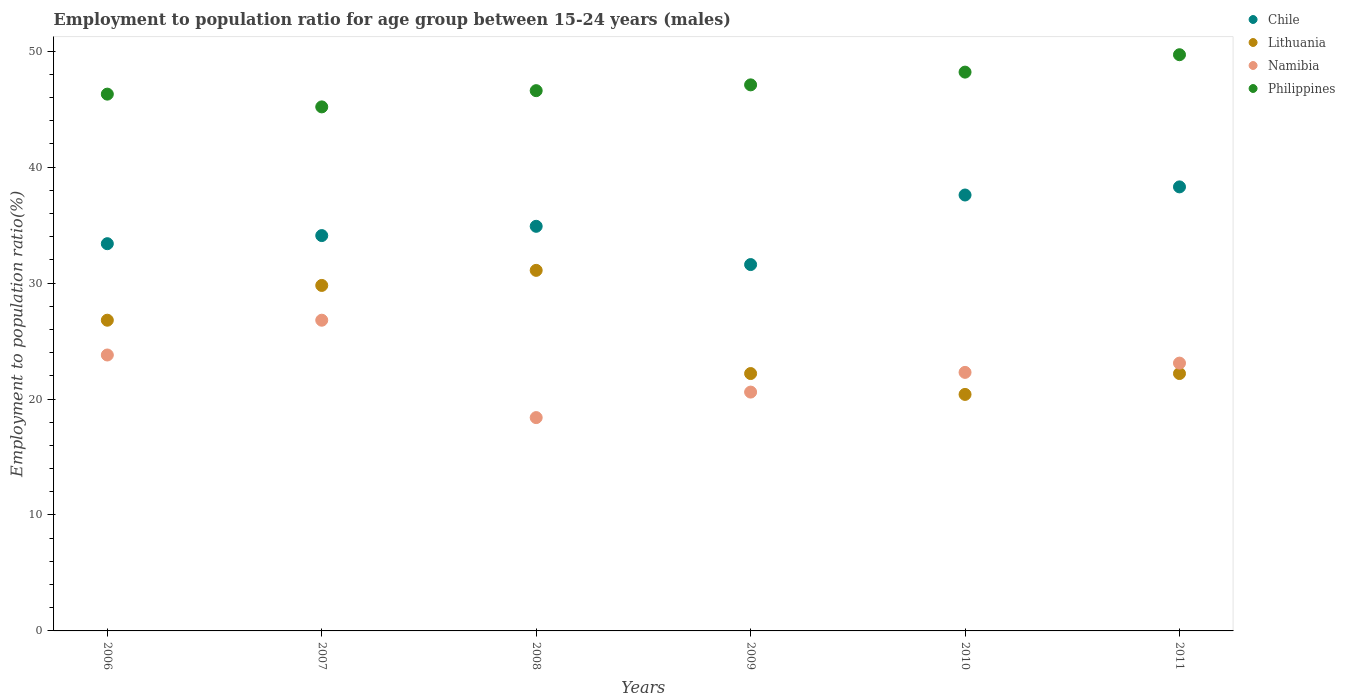What is the employment to population ratio in Namibia in 2009?
Provide a short and direct response. 20.6. Across all years, what is the maximum employment to population ratio in Philippines?
Your answer should be compact. 49.7. Across all years, what is the minimum employment to population ratio in Lithuania?
Your response must be concise. 20.4. In which year was the employment to population ratio in Philippines maximum?
Make the answer very short. 2011. In which year was the employment to population ratio in Philippines minimum?
Make the answer very short. 2007. What is the total employment to population ratio in Namibia in the graph?
Your answer should be very brief. 135. What is the difference between the employment to population ratio in Namibia in 2009 and that in 2010?
Your answer should be compact. -1.7. What is the difference between the employment to population ratio in Lithuania in 2007 and the employment to population ratio in Philippines in 2010?
Give a very brief answer. -18.4. What is the average employment to population ratio in Lithuania per year?
Make the answer very short. 25.42. In the year 2007, what is the difference between the employment to population ratio in Chile and employment to population ratio in Namibia?
Offer a very short reply. 7.3. What is the ratio of the employment to population ratio in Namibia in 2009 to that in 2010?
Give a very brief answer. 0.92. Is the difference between the employment to population ratio in Chile in 2006 and 2007 greater than the difference between the employment to population ratio in Namibia in 2006 and 2007?
Provide a short and direct response. Yes. What is the difference between the highest and the second highest employment to population ratio in Lithuania?
Keep it short and to the point. 1.3. What is the difference between the highest and the lowest employment to population ratio in Lithuania?
Offer a terse response. 10.7. In how many years, is the employment to population ratio in Philippines greater than the average employment to population ratio in Philippines taken over all years?
Give a very brief answer. 2. Does the employment to population ratio in Philippines monotonically increase over the years?
Your answer should be compact. No. How many dotlines are there?
Offer a terse response. 4. Are the values on the major ticks of Y-axis written in scientific E-notation?
Ensure brevity in your answer.  No. Does the graph contain grids?
Your answer should be compact. No. Where does the legend appear in the graph?
Give a very brief answer. Top right. How are the legend labels stacked?
Give a very brief answer. Vertical. What is the title of the graph?
Make the answer very short. Employment to population ratio for age group between 15-24 years (males). What is the label or title of the Y-axis?
Offer a terse response. Employment to population ratio(%). What is the Employment to population ratio(%) of Chile in 2006?
Offer a very short reply. 33.4. What is the Employment to population ratio(%) in Lithuania in 2006?
Offer a very short reply. 26.8. What is the Employment to population ratio(%) in Namibia in 2006?
Provide a short and direct response. 23.8. What is the Employment to population ratio(%) in Philippines in 2006?
Make the answer very short. 46.3. What is the Employment to population ratio(%) of Chile in 2007?
Your answer should be very brief. 34.1. What is the Employment to population ratio(%) in Lithuania in 2007?
Make the answer very short. 29.8. What is the Employment to population ratio(%) of Namibia in 2007?
Your response must be concise. 26.8. What is the Employment to population ratio(%) of Philippines in 2007?
Your answer should be very brief. 45.2. What is the Employment to population ratio(%) of Chile in 2008?
Keep it short and to the point. 34.9. What is the Employment to population ratio(%) in Lithuania in 2008?
Your answer should be compact. 31.1. What is the Employment to population ratio(%) of Namibia in 2008?
Your response must be concise. 18.4. What is the Employment to population ratio(%) in Philippines in 2008?
Your answer should be very brief. 46.6. What is the Employment to population ratio(%) in Chile in 2009?
Keep it short and to the point. 31.6. What is the Employment to population ratio(%) in Lithuania in 2009?
Provide a succinct answer. 22.2. What is the Employment to population ratio(%) in Namibia in 2009?
Provide a short and direct response. 20.6. What is the Employment to population ratio(%) of Philippines in 2009?
Your answer should be compact. 47.1. What is the Employment to population ratio(%) in Chile in 2010?
Provide a short and direct response. 37.6. What is the Employment to population ratio(%) in Lithuania in 2010?
Offer a terse response. 20.4. What is the Employment to population ratio(%) in Namibia in 2010?
Give a very brief answer. 22.3. What is the Employment to population ratio(%) of Philippines in 2010?
Provide a succinct answer. 48.2. What is the Employment to population ratio(%) of Chile in 2011?
Provide a succinct answer. 38.3. What is the Employment to population ratio(%) in Lithuania in 2011?
Keep it short and to the point. 22.2. What is the Employment to population ratio(%) in Namibia in 2011?
Offer a very short reply. 23.1. What is the Employment to population ratio(%) of Philippines in 2011?
Make the answer very short. 49.7. Across all years, what is the maximum Employment to population ratio(%) in Chile?
Ensure brevity in your answer.  38.3. Across all years, what is the maximum Employment to population ratio(%) in Lithuania?
Provide a short and direct response. 31.1. Across all years, what is the maximum Employment to population ratio(%) in Namibia?
Make the answer very short. 26.8. Across all years, what is the maximum Employment to population ratio(%) in Philippines?
Your answer should be compact. 49.7. Across all years, what is the minimum Employment to population ratio(%) in Chile?
Keep it short and to the point. 31.6. Across all years, what is the minimum Employment to population ratio(%) in Lithuania?
Your answer should be compact. 20.4. Across all years, what is the minimum Employment to population ratio(%) of Namibia?
Provide a short and direct response. 18.4. Across all years, what is the minimum Employment to population ratio(%) of Philippines?
Provide a succinct answer. 45.2. What is the total Employment to population ratio(%) in Chile in the graph?
Offer a terse response. 209.9. What is the total Employment to population ratio(%) in Lithuania in the graph?
Ensure brevity in your answer.  152.5. What is the total Employment to population ratio(%) in Namibia in the graph?
Make the answer very short. 135. What is the total Employment to population ratio(%) in Philippines in the graph?
Your answer should be very brief. 283.1. What is the difference between the Employment to population ratio(%) in Chile in 2006 and that in 2007?
Make the answer very short. -0.7. What is the difference between the Employment to population ratio(%) of Lithuania in 2006 and that in 2007?
Make the answer very short. -3. What is the difference between the Employment to population ratio(%) of Namibia in 2006 and that in 2007?
Offer a very short reply. -3. What is the difference between the Employment to population ratio(%) in Lithuania in 2006 and that in 2008?
Your response must be concise. -4.3. What is the difference between the Employment to population ratio(%) in Lithuania in 2006 and that in 2009?
Keep it short and to the point. 4.6. What is the difference between the Employment to population ratio(%) of Namibia in 2006 and that in 2010?
Ensure brevity in your answer.  1.5. What is the difference between the Employment to population ratio(%) of Chile in 2006 and that in 2011?
Provide a succinct answer. -4.9. What is the difference between the Employment to population ratio(%) of Lithuania in 2006 and that in 2011?
Provide a succinct answer. 4.6. What is the difference between the Employment to population ratio(%) in Philippines in 2006 and that in 2011?
Your answer should be very brief. -3.4. What is the difference between the Employment to population ratio(%) of Lithuania in 2007 and that in 2008?
Provide a short and direct response. -1.3. What is the difference between the Employment to population ratio(%) of Philippines in 2007 and that in 2008?
Make the answer very short. -1.4. What is the difference between the Employment to population ratio(%) in Chile in 2007 and that in 2009?
Your response must be concise. 2.5. What is the difference between the Employment to population ratio(%) in Lithuania in 2007 and that in 2009?
Ensure brevity in your answer.  7.6. What is the difference between the Employment to population ratio(%) in Philippines in 2007 and that in 2009?
Offer a terse response. -1.9. What is the difference between the Employment to population ratio(%) of Chile in 2007 and that in 2010?
Give a very brief answer. -3.5. What is the difference between the Employment to population ratio(%) in Namibia in 2007 and that in 2010?
Your answer should be very brief. 4.5. What is the difference between the Employment to population ratio(%) of Chile in 2007 and that in 2011?
Keep it short and to the point. -4.2. What is the difference between the Employment to population ratio(%) of Namibia in 2007 and that in 2011?
Provide a short and direct response. 3.7. What is the difference between the Employment to population ratio(%) of Philippines in 2007 and that in 2011?
Offer a very short reply. -4.5. What is the difference between the Employment to population ratio(%) in Chile in 2008 and that in 2009?
Your answer should be compact. 3.3. What is the difference between the Employment to population ratio(%) of Philippines in 2008 and that in 2009?
Give a very brief answer. -0.5. What is the difference between the Employment to population ratio(%) in Lithuania in 2008 and that in 2010?
Your response must be concise. 10.7. What is the difference between the Employment to population ratio(%) in Philippines in 2008 and that in 2010?
Give a very brief answer. -1.6. What is the difference between the Employment to population ratio(%) of Lithuania in 2008 and that in 2011?
Offer a very short reply. 8.9. What is the difference between the Employment to population ratio(%) of Namibia in 2009 and that in 2010?
Keep it short and to the point. -1.7. What is the difference between the Employment to population ratio(%) of Philippines in 2009 and that in 2010?
Ensure brevity in your answer.  -1.1. What is the difference between the Employment to population ratio(%) of Namibia in 2009 and that in 2011?
Offer a terse response. -2.5. What is the difference between the Employment to population ratio(%) of Philippines in 2009 and that in 2011?
Offer a very short reply. -2.6. What is the difference between the Employment to population ratio(%) of Lithuania in 2010 and that in 2011?
Keep it short and to the point. -1.8. What is the difference between the Employment to population ratio(%) of Namibia in 2010 and that in 2011?
Ensure brevity in your answer.  -0.8. What is the difference between the Employment to population ratio(%) of Chile in 2006 and the Employment to population ratio(%) of Philippines in 2007?
Your response must be concise. -11.8. What is the difference between the Employment to population ratio(%) in Lithuania in 2006 and the Employment to population ratio(%) in Philippines in 2007?
Keep it short and to the point. -18.4. What is the difference between the Employment to population ratio(%) in Namibia in 2006 and the Employment to population ratio(%) in Philippines in 2007?
Your response must be concise. -21.4. What is the difference between the Employment to population ratio(%) in Chile in 2006 and the Employment to population ratio(%) in Lithuania in 2008?
Provide a succinct answer. 2.3. What is the difference between the Employment to population ratio(%) of Chile in 2006 and the Employment to population ratio(%) of Namibia in 2008?
Make the answer very short. 15. What is the difference between the Employment to population ratio(%) in Chile in 2006 and the Employment to population ratio(%) in Philippines in 2008?
Your answer should be very brief. -13.2. What is the difference between the Employment to population ratio(%) in Lithuania in 2006 and the Employment to population ratio(%) in Namibia in 2008?
Offer a terse response. 8.4. What is the difference between the Employment to population ratio(%) in Lithuania in 2006 and the Employment to population ratio(%) in Philippines in 2008?
Give a very brief answer. -19.8. What is the difference between the Employment to population ratio(%) of Namibia in 2006 and the Employment to population ratio(%) of Philippines in 2008?
Ensure brevity in your answer.  -22.8. What is the difference between the Employment to population ratio(%) in Chile in 2006 and the Employment to population ratio(%) in Lithuania in 2009?
Make the answer very short. 11.2. What is the difference between the Employment to population ratio(%) of Chile in 2006 and the Employment to population ratio(%) of Namibia in 2009?
Your response must be concise. 12.8. What is the difference between the Employment to population ratio(%) of Chile in 2006 and the Employment to population ratio(%) of Philippines in 2009?
Keep it short and to the point. -13.7. What is the difference between the Employment to population ratio(%) in Lithuania in 2006 and the Employment to population ratio(%) in Philippines in 2009?
Ensure brevity in your answer.  -20.3. What is the difference between the Employment to population ratio(%) of Namibia in 2006 and the Employment to population ratio(%) of Philippines in 2009?
Provide a succinct answer. -23.3. What is the difference between the Employment to population ratio(%) of Chile in 2006 and the Employment to population ratio(%) of Namibia in 2010?
Keep it short and to the point. 11.1. What is the difference between the Employment to population ratio(%) of Chile in 2006 and the Employment to population ratio(%) of Philippines in 2010?
Give a very brief answer. -14.8. What is the difference between the Employment to population ratio(%) of Lithuania in 2006 and the Employment to population ratio(%) of Namibia in 2010?
Keep it short and to the point. 4.5. What is the difference between the Employment to population ratio(%) in Lithuania in 2006 and the Employment to population ratio(%) in Philippines in 2010?
Your response must be concise. -21.4. What is the difference between the Employment to population ratio(%) in Namibia in 2006 and the Employment to population ratio(%) in Philippines in 2010?
Keep it short and to the point. -24.4. What is the difference between the Employment to population ratio(%) in Chile in 2006 and the Employment to population ratio(%) in Lithuania in 2011?
Give a very brief answer. 11.2. What is the difference between the Employment to population ratio(%) of Chile in 2006 and the Employment to population ratio(%) of Namibia in 2011?
Your answer should be very brief. 10.3. What is the difference between the Employment to population ratio(%) of Chile in 2006 and the Employment to population ratio(%) of Philippines in 2011?
Make the answer very short. -16.3. What is the difference between the Employment to population ratio(%) of Lithuania in 2006 and the Employment to population ratio(%) of Namibia in 2011?
Offer a terse response. 3.7. What is the difference between the Employment to population ratio(%) of Lithuania in 2006 and the Employment to population ratio(%) of Philippines in 2011?
Keep it short and to the point. -22.9. What is the difference between the Employment to population ratio(%) of Namibia in 2006 and the Employment to population ratio(%) of Philippines in 2011?
Offer a terse response. -25.9. What is the difference between the Employment to population ratio(%) of Chile in 2007 and the Employment to population ratio(%) of Namibia in 2008?
Provide a succinct answer. 15.7. What is the difference between the Employment to population ratio(%) in Lithuania in 2007 and the Employment to population ratio(%) in Philippines in 2008?
Offer a very short reply. -16.8. What is the difference between the Employment to population ratio(%) of Namibia in 2007 and the Employment to population ratio(%) of Philippines in 2008?
Make the answer very short. -19.8. What is the difference between the Employment to population ratio(%) in Chile in 2007 and the Employment to population ratio(%) in Lithuania in 2009?
Make the answer very short. 11.9. What is the difference between the Employment to population ratio(%) in Chile in 2007 and the Employment to population ratio(%) in Namibia in 2009?
Your answer should be compact. 13.5. What is the difference between the Employment to population ratio(%) of Lithuania in 2007 and the Employment to population ratio(%) of Namibia in 2009?
Your response must be concise. 9.2. What is the difference between the Employment to population ratio(%) in Lithuania in 2007 and the Employment to population ratio(%) in Philippines in 2009?
Keep it short and to the point. -17.3. What is the difference between the Employment to population ratio(%) in Namibia in 2007 and the Employment to population ratio(%) in Philippines in 2009?
Give a very brief answer. -20.3. What is the difference between the Employment to population ratio(%) of Chile in 2007 and the Employment to population ratio(%) of Namibia in 2010?
Ensure brevity in your answer.  11.8. What is the difference between the Employment to population ratio(%) of Chile in 2007 and the Employment to population ratio(%) of Philippines in 2010?
Your response must be concise. -14.1. What is the difference between the Employment to population ratio(%) of Lithuania in 2007 and the Employment to population ratio(%) of Namibia in 2010?
Ensure brevity in your answer.  7.5. What is the difference between the Employment to population ratio(%) in Lithuania in 2007 and the Employment to population ratio(%) in Philippines in 2010?
Your answer should be compact. -18.4. What is the difference between the Employment to population ratio(%) in Namibia in 2007 and the Employment to population ratio(%) in Philippines in 2010?
Keep it short and to the point. -21.4. What is the difference between the Employment to population ratio(%) of Chile in 2007 and the Employment to population ratio(%) of Lithuania in 2011?
Provide a succinct answer. 11.9. What is the difference between the Employment to population ratio(%) in Chile in 2007 and the Employment to population ratio(%) in Philippines in 2011?
Your response must be concise. -15.6. What is the difference between the Employment to population ratio(%) in Lithuania in 2007 and the Employment to population ratio(%) in Philippines in 2011?
Your response must be concise. -19.9. What is the difference between the Employment to population ratio(%) of Namibia in 2007 and the Employment to population ratio(%) of Philippines in 2011?
Ensure brevity in your answer.  -22.9. What is the difference between the Employment to population ratio(%) of Chile in 2008 and the Employment to population ratio(%) of Lithuania in 2009?
Give a very brief answer. 12.7. What is the difference between the Employment to population ratio(%) in Chile in 2008 and the Employment to population ratio(%) in Namibia in 2009?
Provide a succinct answer. 14.3. What is the difference between the Employment to population ratio(%) of Lithuania in 2008 and the Employment to population ratio(%) of Namibia in 2009?
Your response must be concise. 10.5. What is the difference between the Employment to population ratio(%) in Lithuania in 2008 and the Employment to population ratio(%) in Philippines in 2009?
Provide a succinct answer. -16. What is the difference between the Employment to population ratio(%) of Namibia in 2008 and the Employment to population ratio(%) of Philippines in 2009?
Ensure brevity in your answer.  -28.7. What is the difference between the Employment to population ratio(%) in Chile in 2008 and the Employment to population ratio(%) in Philippines in 2010?
Give a very brief answer. -13.3. What is the difference between the Employment to population ratio(%) in Lithuania in 2008 and the Employment to population ratio(%) in Philippines in 2010?
Provide a succinct answer. -17.1. What is the difference between the Employment to population ratio(%) in Namibia in 2008 and the Employment to population ratio(%) in Philippines in 2010?
Ensure brevity in your answer.  -29.8. What is the difference between the Employment to population ratio(%) of Chile in 2008 and the Employment to population ratio(%) of Lithuania in 2011?
Keep it short and to the point. 12.7. What is the difference between the Employment to population ratio(%) of Chile in 2008 and the Employment to population ratio(%) of Philippines in 2011?
Your response must be concise. -14.8. What is the difference between the Employment to population ratio(%) of Lithuania in 2008 and the Employment to population ratio(%) of Philippines in 2011?
Your answer should be compact. -18.6. What is the difference between the Employment to population ratio(%) in Namibia in 2008 and the Employment to population ratio(%) in Philippines in 2011?
Provide a short and direct response. -31.3. What is the difference between the Employment to population ratio(%) of Chile in 2009 and the Employment to population ratio(%) of Namibia in 2010?
Your answer should be very brief. 9.3. What is the difference between the Employment to population ratio(%) in Chile in 2009 and the Employment to population ratio(%) in Philippines in 2010?
Offer a terse response. -16.6. What is the difference between the Employment to population ratio(%) of Lithuania in 2009 and the Employment to population ratio(%) of Philippines in 2010?
Make the answer very short. -26. What is the difference between the Employment to population ratio(%) in Namibia in 2009 and the Employment to population ratio(%) in Philippines in 2010?
Give a very brief answer. -27.6. What is the difference between the Employment to population ratio(%) in Chile in 2009 and the Employment to population ratio(%) in Lithuania in 2011?
Make the answer very short. 9.4. What is the difference between the Employment to population ratio(%) in Chile in 2009 and the Employment to population ratio(%) in Philippines in 2011?
Offer a very short reply. -18.1. What is the difference between the Employment to population ratio(%) of Lithuania in 2009 and the Employment to population ratio(%) of Philippines in 2011?
Provide a short and direct response. -27.5. What is the difference between the Employment to population ratio(%) in Namibia in 2009 and the Employment to population ratio(%) in Philippines in 2011?
Make the answer very short. -29.1. What is the difference between the Employment to population ratio(%) in Chile in 2010 and the Employment to population ratio(%) in Namibia in 2011?
Provide a succinct answer. 14.5. What is the difference between the Employment to population ratio(%) in Chile in 2010 and the Employment to population ratio(%) in Philippines in 2011?
Your answer should be compact. -12.1. What is the difference between the Employment to population ratio(%) of Lithuania in 2010 and the Employment to population ratio(%) of Namibia in 2011?
Provide a short and direct response. -2.7. What is the difference between the Employment to population ratio(%) of Lithuania in 2010 and the Employment to population ratio(%) of Philippines in 2011?
Give a very brief answer. -29.3. What is the difference between the Employment to population ratio(%) in Namibia in 2010 and the Employment to population ratio(%) in Philippines in 2011?
Your answer should be compact. -27.4. What is the average Employment to population ratio(%) of Chile per year?
Offer a very short reply. 34.98. What is the average Employment to population ratio(%) in Lithuania per year?
Offer a very short reply. 25.42. What is the average Employment to population ratio(%) in Namibia per year?
Your response must be concise. 22.5. What is the average Employment to population ratio(%) in Philippines per year?
Give a very brief answer. 47.18. In the year 2006, what is the difference between the Employment to population ratio(%) in Lithuania and Employment to population ratio(%) in Philippines?
Your response must be concise. -19.5. In the year 2006, what is the difference between the Employment to population ratio(%) of Namibia and Employment to population ratio(%) of Philippines?
Offer a very short reply. -22.5. In the year 2007, what is the difference between the Employment to population ratio(%) of Chile and Employment to population ratio(%) of Namibia?
Your answer should be very brief. 7.3. In the year 2007, what is the difference between the Employment to population ratio(%) in Chile and Employment to population ratio(%) in Philippines?
Ensure brevity in your answer.  -11.1. In the year 2007, what is the difference between the Employment to population ratio(%) in Lithuania and Employment to population ratio(%) in Philippines?
Keep it short and to the point. -15.4. In the year 2007, what is the difference between the Employment to population ratio(%) of Namibia and Employment to population ratio(%) of Philippines?
Keep it short and to the point. -18.4. In the year 2008, what is the difference between the Employment to population ratio(%) in Chile and Employment to population ratio(%) in Lithuania?
Provide a short and direct response. 3.8. In the year 2008, what is the difference between the Employment to population ratio(%) in Chile and Employment to population ratio(%) in Philippines?
Ensure brevity in your answer.  -11.7. In the year 2008, what is the difference between the Employment to population ratio(%) of Lithuania and Employment to population ratio(%) of Philippines?
Your response must be concise. -15.5. In the year 2008, what is the difference between the Employment to population ratio(%) of Namibia and Employment to population ratio(%) of Philippines?
Make the answer very short. -28.2. In the year 2009, what is the difference between the Employment to population ratio(%) of Chile and Employment to population ratio(%) of Lithuania?
Provide a short and direct response. 9.4. In the year 2009, what is the difference between the Employment to population ratio(%) of Chile and Employment to population ratio(%) of Philippines?
Your answer should be compact. -15.5. In the year 2009, what is the difference between the Employment to population ratio(%) in Lithuania and Employment to population ratio(%) in Philippines?
Give a very brief answer. -24.9. In the year 2009, what is the difference between the Employment to population ratio(%) of Namibia and Employment to population ratio(%) of Philippines?
Ensure brevity in your answer.  -26.5. In the year 2010, what is the difference between the Employment to population ratio(%) in Chile and Employment to population ratio(%) in Lithuania?
Give a very brief answer. 17.2. In the year 2010, what is the difference between the Employment to population ratio(%) in Chile and Employment to population ratio(%) in Philippines?
Make the answer very short. -10.6. In the year 2010, what is the difference between the Employment to population ratio(%) of Lithuania and Employment to population ratio(%) of Namibia?
Keep it short and to the point. -1.9. In the year 2010, what is the difference between the Employment to population ratio(%) in Lithuania and Employment to population ratio(%) in Philippines?
Offer a very short reply. -27.8. In the year 2010, what is the difference between the Employment to population ratio(%) in Namibia and Employment to population ratio(%) in Philippines?
Provide a short and direct response. -25.9. In the year 2011, what is the difference between the Employment to population ratio(%) of Lithuania and Employment to population ratio(%) of Philippines?
Give a very brief answer. -27.5. In the year 2011, what is the difference between the Employment to population ratio(%) in Namibia and Employment to population ratio(%) in Philippines?
Your answer should be very brief. -26.6. What is the ratio of the Employment to population ratio(%) of Chile in 2006 to that in 2007?
Your answer should be very brief. 0.98. What is the ratio of the Employment to population ratio(%) of Lithuania in 2006 to that in 2007?
Offer a terse response. 0.9. What is the ratio of the Employment to population ratio(%) of Namibia in 2006 to that in 2007?
Provide a succinct answer. 0.89. What is the ratio of the Employment to population ratio(%) in Philippines in 2006 to that in 2007?
Offer a terse response. 1.02. What is the ratio of the Employment to population ratio(%) in Lithuania in 2006 to that in 2008?
Your response must be concise. 0.86. What is the ratio of the Employment to population ratio(%) of Namibia in 2006 to that in 2008?
Give a very brief answer. 1.29. What is the ratio of the Employment to population ratio(%) in Philippines in 2006 to that in 2008?
Your answer should be compact. 0.99. What is the ratio of the Employment to population ratio(%) of Chile in 2006 to that in 2009?
Offer a very short reply. 1.06. What is the ratio of the Employment to population ratio(%) in Lithuania in 2006 to that in 2009?
Give a very brief answer. 1.21. What is the ratio of the Employment to population ratio(%) of Namibia in 2006 to that in 2009?
Your answer should be very brief. 1.16. What is the ratio of the Employment to population ratio(%) of Philippines in 2006 to that in 2009?
Provide a short and direct response. 0.98. What is the ratio of the Employment to population ratio(%) in Chile in 2006 to that in 2010?
Your response must be concise. 0.89. What is the ratio of the Employment to population ratio(%) of Lithuania in 2006 to that in 2010?
Your answer should be compact. 1.31. What is the ratio of the Employment to population ratio(%) of Namibia in 2006 to that in 2010?
Keep it short and to the point. 1.07. What is the ratio of the Employment to population ratio(%) of Philippines in 2006 to that in 2010?
Give a very brief answer. 0.96. What is the ratio of the Employment to population ratio(%) of Chile in 2006 to that in 2011?
Give a very brief answer. 0.87. What is the ratio of the Employment to population ratio(%) in Lithuania in 2006 to that in 2011?
Your answer should be compact. 1.21. What is the ratio of the Employment to population ratio(%) in Namibia in 2006 to that in 2011?
Your answer should be very brief. 1.03. What is the ratio of the Employment to population ratio(%) of Philippines in 2006 to that in 2011?
Offer a terse response. 0.93. What is the ratio of the Employment to population ratio(%) of Chile in 2007 to that in 2008?
Your answer should be compact. 0.98. What is the ratio of the Employment to population ratio(%) in Lithuania in 2007 to that in 2008?
Make the answer very short. 0.96. What is the ratio of the Employment to population ratio(%) of Namibia in 2007 to that in 2008?
Give a very brief answer. 1.46. What is the ratio of the Employment to population ratio(%) of Philippines in 2007 to that in 2008?
Offer a very short reply. 0.97. What is the ratio of the Employment to population ratio(%) of Chile in 2007 to that in 2009?
Offer a terse response. 1.08. What is the ratio of the Employment to population ratio(%) in Lithuania in 2007 to that in 2009?
Make the answer very short. 1.34. What is the ratio of the Employment to population ratio(%) in Namibia in 2007 to that in 2009?
Provide a succinct answer. 1.3. What is the ratio of the Employment to population ratio(%) of Philippines in 2007 to that in 2009?
Ensure brevity in your answer.  0.96. What is the ratio of the Employment to population ratio(%) in Chile in 2007 to that in 2010?
Offer a terse response. 0.91. What is the ratio of the Employment to population ratio(%) of Lithuania in 2007 to that in 2010?
Offer a terse response. 1.46. What is the ratio of the Employment to population ratio(%) of Namibia in 2007 to that in 2010?
Ensure brevity in your answer.  1.2. What is the ratio of the Employment to population ratio(%) in Philippines in 2007 to that in 2010?
Ensure brevity in your answer.  0.94. What is the ratio of the Employment to population ratio(%) of Chile in 2007 to that in 2011?
Provide a short and direct response. 0.89. What is the ratio of the Employment to population ratio(%) in Lithuania in 2007 to that in 2011?
Your answer should be compact. 1.34. What is the ratio of the Employment to population ratio(%) in Namibia in 2007 to that in 2011?
Ensure brevity in your answer.  1.16. What is the ratio of the Employment to population ratio(%) of Philippines in 2007 to that in 2011?
Provide a succinct answer. 0.91. What is the ratio of the Employment to population ratio(%) of Chile in 2008 to that in 2009?
Keep it short and to the point. 1.1. What is the ratio of the Employment to population ratio(%) in Lithuania in 2008 to that in 2009?
Your answer should be very brief. 1.4. What is the ratio of the Employment to population ratio(%) in Namibia in 2008 to that in 2009?
Your answer should be very brief. 0.89. What is the ratio of the Employment to population ratio(%) of Chile in 2008 to that in 2010?
Ensure brevity in your answer.  0.93. What is the ratio of the Employment to population ratio(%) in Lithuania in 2008 to that in 2010?
Your answer should be very brief. 1.52. What is the ratio of the Employment to population ratio(%) in Namibia in 2008 to that in 2010?
Make the answer very short. 0.83. What is the ratio of the Employment to population ratio(%) in Philippines in 2008 to that in 2010?
Keep it short and to the point. 0.97. What is the ratio of the Employment to population ratio(%) in Chile in 2008 to that in 2011?
Offer a terse response. 0.91. What is the ratio of the Employment to population ratio(%) in Lithuania in 2008 to that in 2011?
Your answer should be very brief. 1.4. What is the ratio of the Employment to population ratio(%) of Namibia in 2008 to that in 2011?
Offer a very short reply. 0.8. What is the ratio of the Employment to population ratio(%) of Philippines in 2008 to that in 2011?
Ensure brevity in your answer.  0.94. What is the ratio of the Employment to population ratio(%) in Chile in 2009 to that in 2010?
Ensure brevity in your answer.  0.84. What is the ratio of the Employment to population ratio(%) in Lithuania in 2009 to that in 2010?
Make the answer very short. 1.09. What is the ratio of the Employment to population ratio(%) of Namibia in 2009 to that in 2010?
Keep it short and to the point. 0.92. What is the ratio of the Employment to population ratio(%) in Philippines in 2009 to that in 2010?
Give a very brief answer. 0.98. What is the ratio of the Employment to population ratio(%) of Chile in 2009 to that in 2011?
Make the answer very short. 0.83. What is the ratio of the Employment to population ratio(%) in Namibia in 2009 to that in 2011?
Make the answer very short. 0.89. What is the ratio of the Employment to population ratio(%) of Philippines in 2009 to that in 2011?
Provide a short and direct response. 0.95. What is the ratio of the Employment to population ratio(%) in Chile in 2010 to that in 2011?
Your answer should be very brief. 0.98. What is the ratio of the Employment to population ratio(%) in Lithuania in 2010 to that in 2011?
Your response must be concise. 0.92. What is the ratio of the Employment to population ratio(%) in Namibia in 2010 to that in 2011?
Offer a very short reply. 0.97. What is the ratio of the Employment to population ratio(%) of Philippines in 2010 to that in 2011?
Offer a very short reply. 0.97. What is the difference between the highest and the lowest Employment to population ratio(%) of Chile?
Your answer should be compact. 6.7. What is the difference between the highest and the lowest Employment to population ratio(%) in Philippines?
Provide a succinct answer. 4.5. 